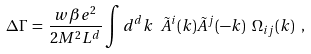<formula> <loc_0><loc_0><loc_500><loc_500>\Delta \Gamma \, = \, \frac { w \beta e ^ { 2 } } { 2 M ^ { 2 } L ^ { d } } \int d ^ { d } k \ \tilde { A } ^ { i } ( k ) \tilde { A } ^ { j } ( - k ) \ \Omega _ { i j } ( k ) \ ,</formula> 